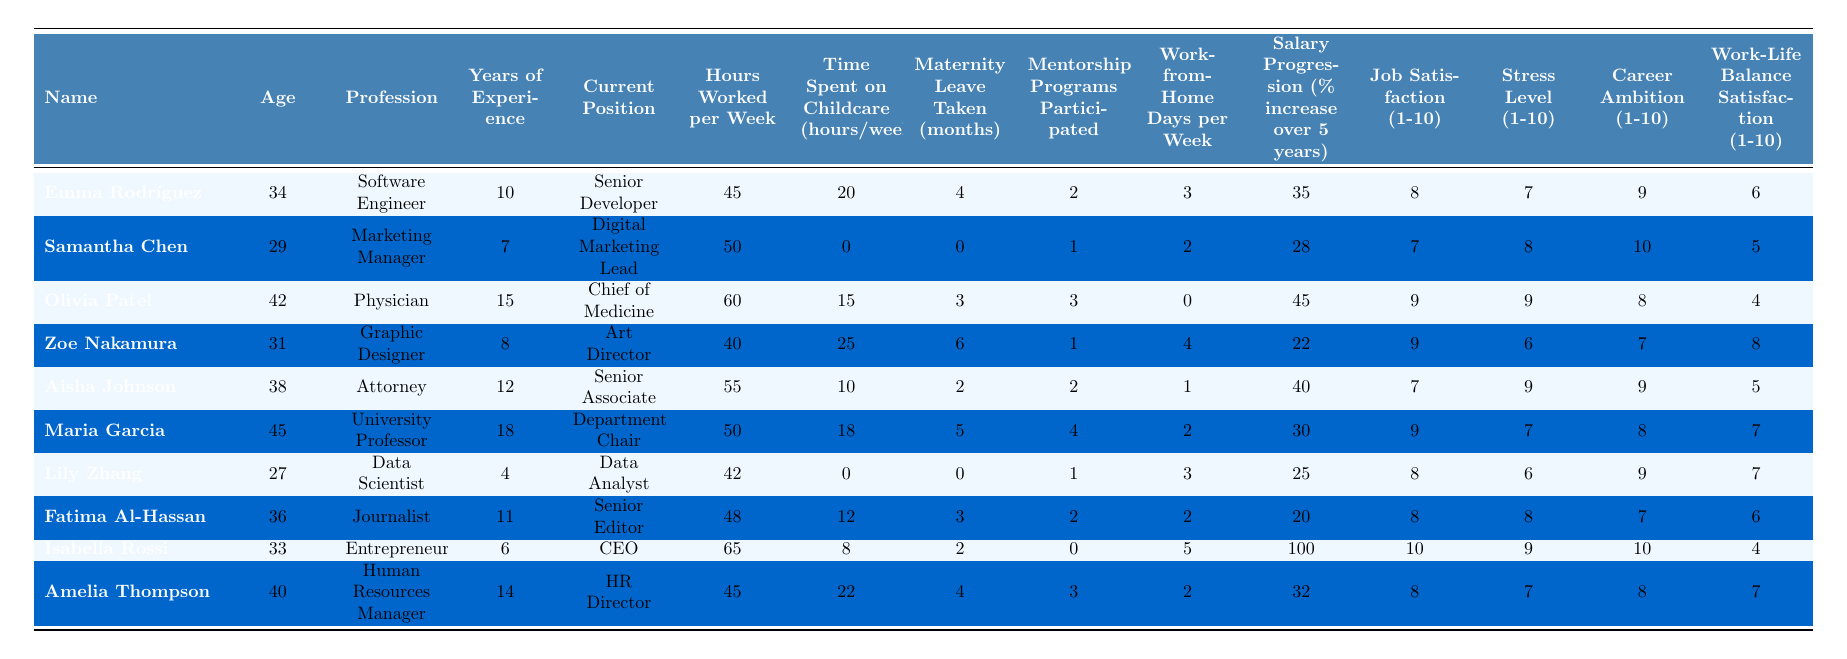What is the average salary progression for the women in this table? To find the average salary progression, I will sum the salary progression percentages (35 + 28 + 45 + 22 + 40 + 30 + 25 + 20 + 100 + 32) = 407. There are 10 entries, so the average is 407/10 = 40.7.
Answer: 40.7 How many women took more than 4 months of maternity leave? I will count the individuals with maternity leave taken greater than 4 months. From the table, Emma Rodríguez (4), Olivia Patel (3), Aisha Johnson (2), Maria Garcia (5) each had 4 or fewer months, so only Maria Garcia took more than 4 months. In total, 1 woman took more than 4 months of maternity leave.
Answer: 1 Which profession has the highest job satisfaction score? By inspecting the job satisfaction scores, I see Olivia Patel (9), Maria Garcia (9), and Isabella Rossi (10). Isabella Rossi has the highest satisfaction score of 10.
Answer: Isabella Rossi Did any woman work less than 40 hours per week? I will check the "Hours Worked per Week" column for any values below 40. Zoe Nakamura (40), Aisha Johnson (55), Maria Garcia (50), Lily Zhang (42), Fatima Al-Hassan (48), and Isabella Rossi (65), all are 40 or above. Therefore, no woman worked less than 40 hours per week.
Answer: No What is the total time spent on childcare (in hours/week) for all women in this table? I will sum the time spent on childcare from each individual: 20 (Emma) + 0 (Samantha) + 15 (Olivia) + 25 (Zoe) + 10 (Aisha) + 18 (Maria) + 0 (Lily) + 12 (Fatima) + 8 (Isabella) + 22 (Amelia) =  20 + 0 + 15 + 25 + 10 + 18 + 0 + 12 + 8 + 22 = 130 hours/week total.
Answer: 130 What is the correlation between career ambition and work-life balance satisfaction? I will analyze both columns, by comparing the scores of each individual: (Emma: 9, 6), (Samantha: 10, 5), (Olivia: 8, 4), (Zoe: 7, 8), (Aisha: 9, 5), (Maria: 8, 7), (Lily: 9, 7), (Fatima: 7, 6), (Isabella: 10, 4), (Amelia: 8, 7). The scores don't have a clear trend; high ambition doesn't necessarily mean high work-life satisfaction.
Answer: No clear correlation How many women have a work-life balance satisfaction score of 6 or lower? I will look at the "Work-Life Balance Satisfaction" column and count anyone with scores 6 or lower: Emma (6), Samantha (5), Olivia (4), Isabella (4), Fatima (6). That totals 5 women with a score of 6 or lower.
Answer: 5 What is the average age of women who hold the position of CEO? From the table, only Isabella Rossi holds the position of CEO, and her age is 33. Since there is only one data point, the average age is simply 33.
Answer: 33 Which woman has the least years of experience, and what is her profession? I will check the "Years of Experience" for each woman. Lily Zhang has 4 years of experience, the lowest among all. Her profession is Data Scientist.
Answer: Lily Zhang, Data Scientist 